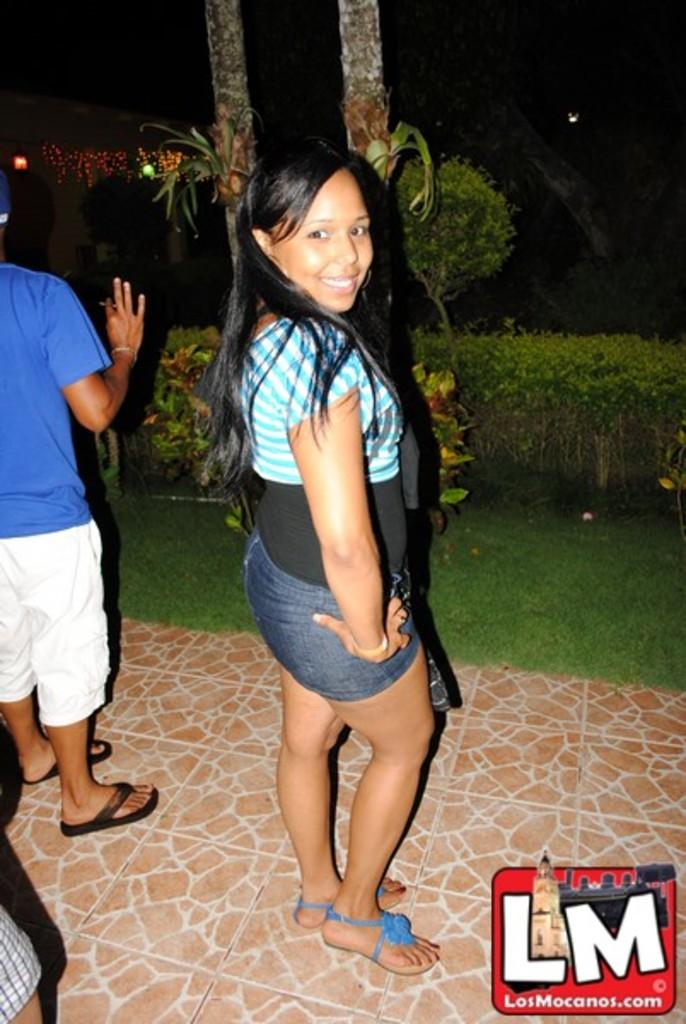What is happening in the image? There are people standing in the image. What can be seen in the background of the image? There are trees and plants in the background of the image. How would you describe the lighting in the image? The background of the image is dark. Is there any text or symbol present in the image? Yes, there is a logo at the bottom right corner of the image. What type of sail can be seen in the image? There is no sail present in the image. Who is the manager of the group in the image? The image does not provide information about a group or a manager. 